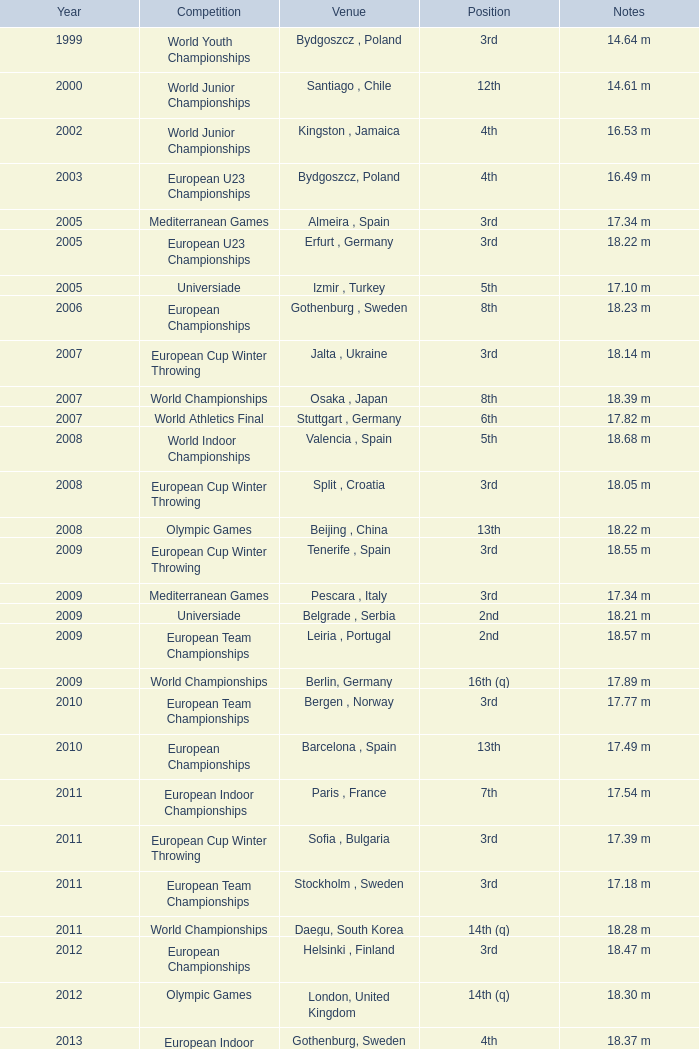What position is 1999? 3rd. 